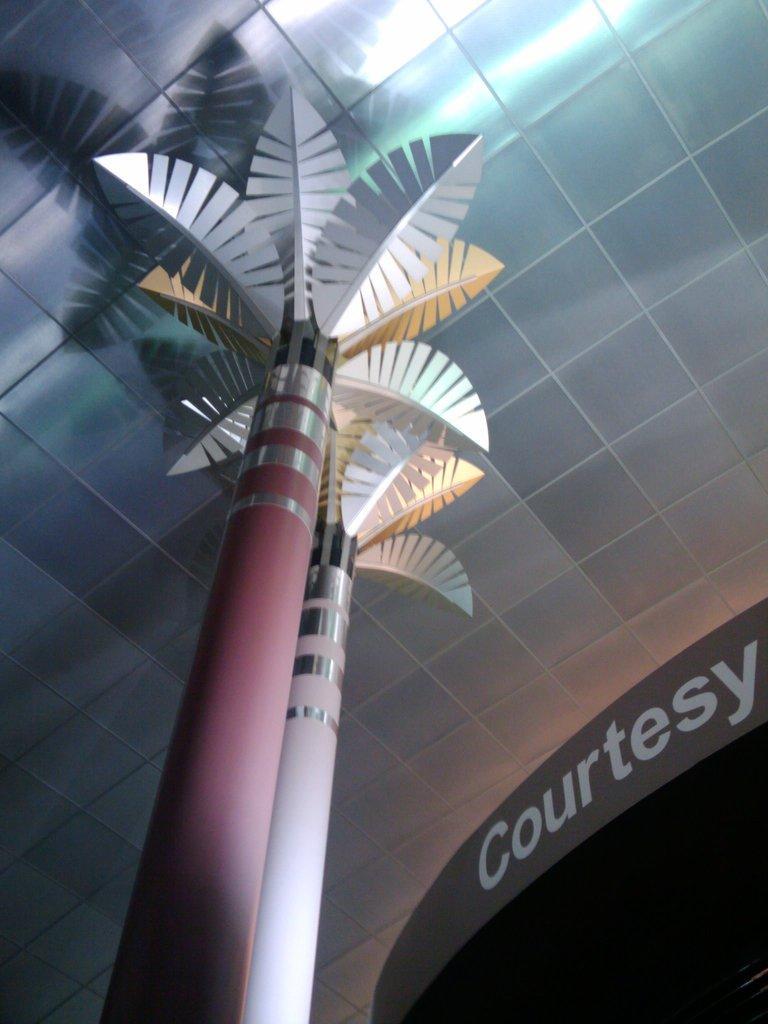Could you give a brief overview of what you see in this image? Here in this picture we can see an artificial tree present on a pole and in the front of it we can see some text present on the wall. 